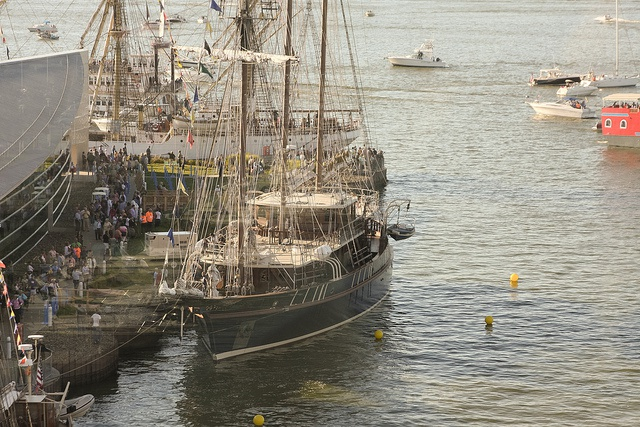Describe the objects in this image and their specific colors. I can see boat in lightgray, black, gray, and darkgray tones, people in lightgray, black, gray, and darkgray tones, boat in lightgray, gray, black, and darkgray tones, boat in lightgray, salmon, tan, darkgray, and beige tones, and boat in lightgray, darkgray, and tan tones in this image. 